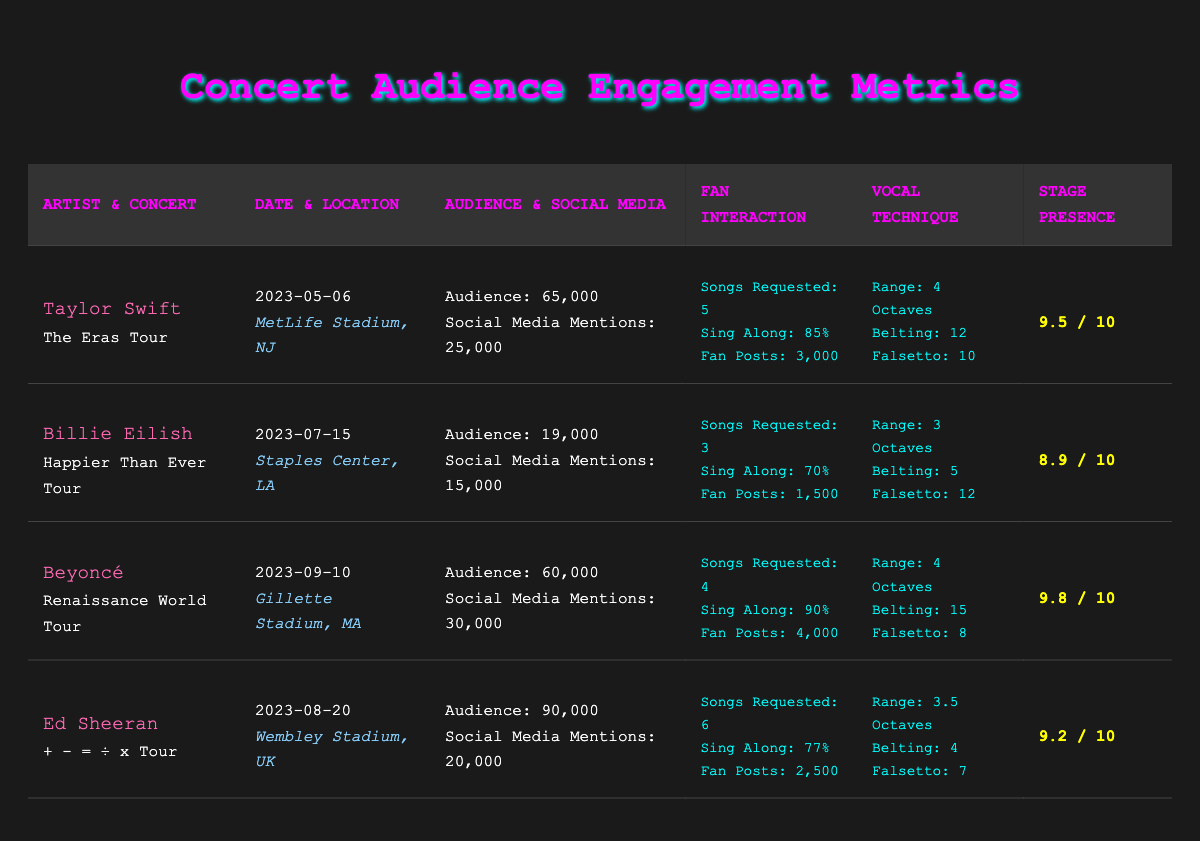What is the audience size for the Taylor Swift concert? The audience size for Taylor Swift's concert "The Eras Tour" is given directly in the table, which states it as 65,000 people.
Answer: 65,000 Which concert had the highest stage presence rating? By comparing the stage presence ratings listed in the table, the highest rating is a 9.8, which corresponds to Beyoncé's "Renaissance World Tour."
Answer: 9.8 How many songs were requested by the fans at Ed Sheeran's concert? In the table, the fan interaction details for Ed Sheeran's concert shows that 6 songs were requested by the fans.
Answer: 6 What is the difference in the number of social media mentions between Taylor Swift and Billie Eilish? Taylor Swift has 25,000 social media mentions and Billie Eilish has 15,000. The difference is calculated as 25,000 - 15,000 = 10,000.
Answer: 10,000 Was the audience sing-along percentage for Beyoncé higher than 85%? The table indicates that Beyoncé's audience sing-along percentage was 90%, which is indeed higher than 85%.
Answer: Yes What is the average audience size across all four concerts? To find the average audience size, we first sum the audience sizes: 65,000 + 19,000 + 60,000 + 90,000 = 234,000. Then, we divide by the number of concerts (4) to get the average: 234,000 / 4 = 58,500.
Answer: 58,500 How many more fan social media posts did Beyoncé receive compared to Billie Eilish? Beyoncé’s fan social media posts amount to 4,000 while Billie Eilish received 1,500. The difference is calculated as 4,000 - 1,500 = 2,500.
Answer: 2,500 What is the total number of songs requested across all concerts? By summing the songs requested from each concert: 5 (Taylor Swift) + 3 (Billie Eilish) + 4 (Beyoncé) + 6 (Ed Sheeran) = 18 songs requested in total.
Answer: 18 Which artist had the highest use of belting technique? Reviewing the table, Beyoncé had the highest use of belting at 15, compared to the others: Taylor Swift with 12, Billie Eilish with 5, and Ed Sheeran with 4.
Answer: Beyoncé 